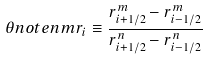<formula> <loc_0><loc_0><loc_500><loc_500>\theta n o t e { n } { m } r _ { i } \equiv \frac { r _ { i + 1 / 2 } ^ { m } - r _ { i - 1 / 2 } ^ { m } } { r _ { i + 1 / 2 } ^ { n } - r _ { i - 1 / 2 } ^ { n } }</formula> 